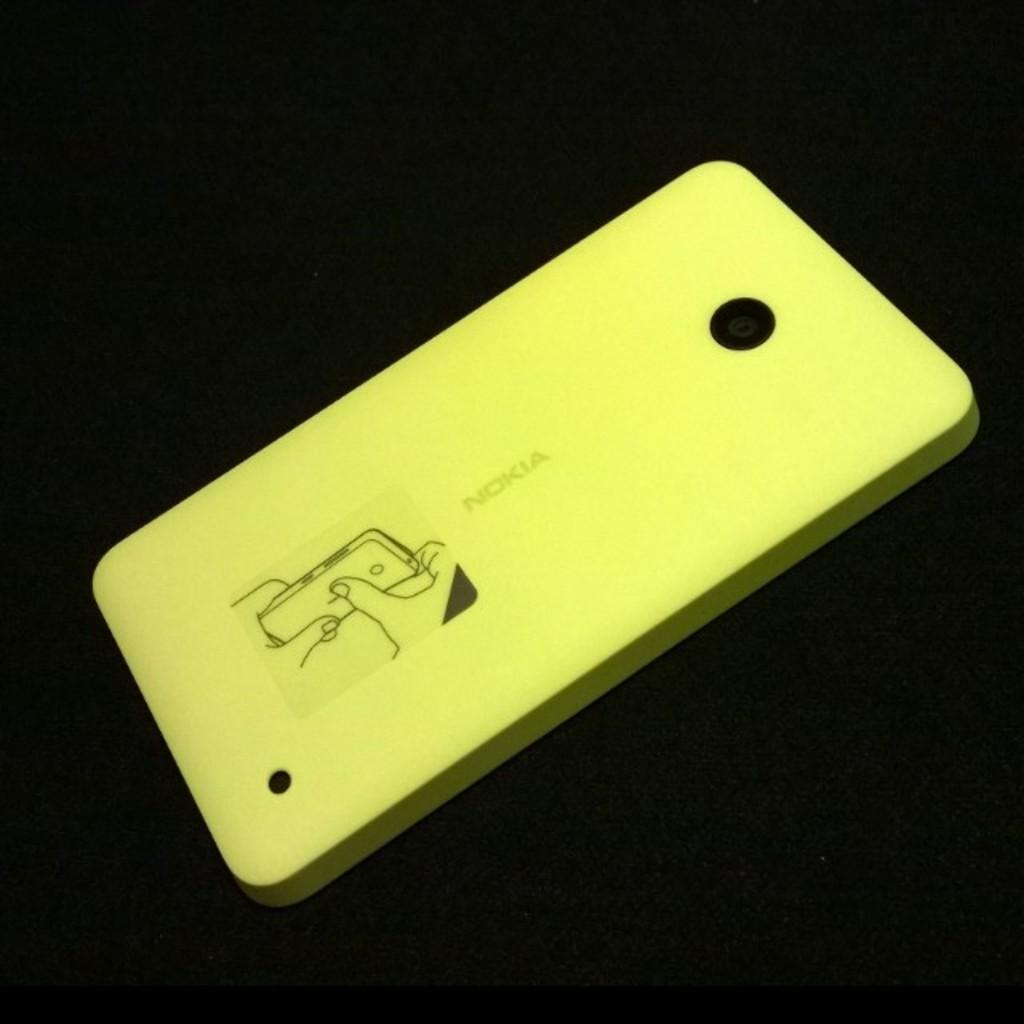<image>
Render a clear and concise summary of the photo. A yellow Nokia phone with a sticker depicting the phone. 